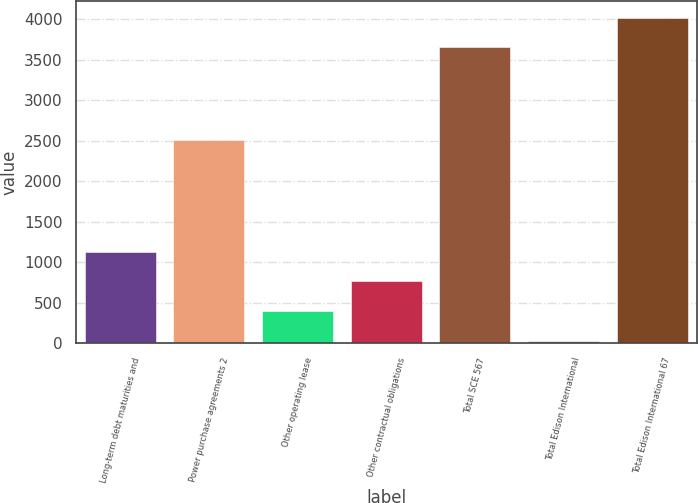Convert chart. <chart><loc_0><loc_0><loc_500><loc_500><bar_chart><fcel>Long-term debt maturities and<fcel>Power purchase agreements 2<fcel>Other operating lease<fcel>Other contractual obligations<fcel>Total SCE 567<fcel>Total Edison International<fcel>Total Edison International 67<nl><fcel>1131.5<fcel>2513<fcel>400.5<fcel>766<fcel>3655<fcel>35<fcel>4020.5<nl></chart> 